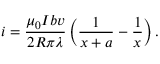<formula> <loc_0><loc_0><loc_500><loc_500>i = \frac { \mu _ { 0 } I b v } { 2 R \pi \lambda } \left ( \frac { 1 } { x + a } - \frac { 1 } { x } \right ) .</formula> 